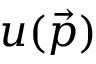Convert formula to latex. <formula><loc_0><loc_0><loc_500><loc_500>u ( { \vec { p } } )</formula> 